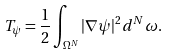<formula> <loc_0><loc_0><loc_500><loc_500>T _ { \psi } = \frac { 1 } { 2 } \int _ { \Omega ^ { N } } | \nabla \psi | ^ { 2 } d ^ { N } \omega .</formula> 